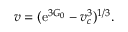<formula> <loc_0><loc_0><loc_500><loc_500>v = ( e ^ { 3 G _ { 0 } } - v _ { c } ^ { 3 } ) ^ { 1 / 3 } .</formula> 